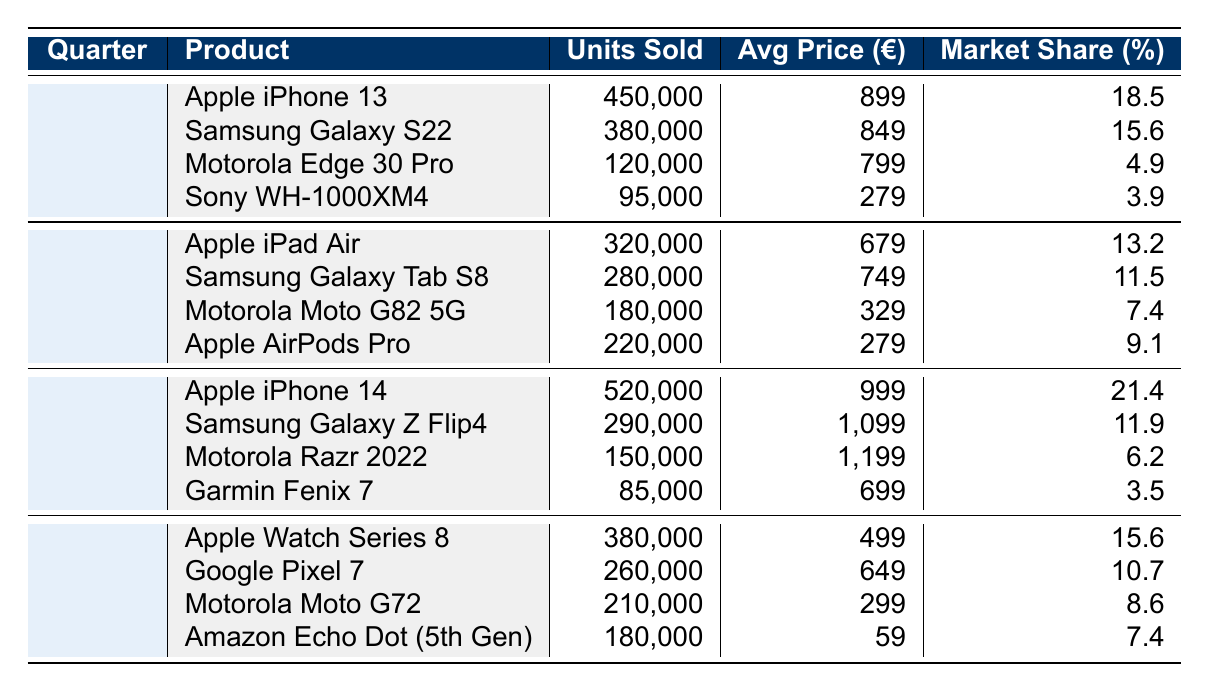What was the best-selling product in Q1 2022? In Q1 2022, the table shows that the Apple iPhone 13 sold 450,000 units, which is more than any other product listed for that quarter.
Answer: Apple iPhone 13 What was the average price of Motorola products sold in Q2 2022? In Q2 2022, the Motorola Moto G82 5G sold for 329€ and there were no other Motorola products listed for that quarter. Therefore, the average price is the same as the price of this one product: 329€.
Answer: 329€ Did the Samsung Galaxy S22 have a higher market share than the Motorola Edge 30 Pro in Q1 2022? The Samsung Galaxy S22 has a market share of 15.6% while the Motorola Edge 30 Pro has a market share of 4.9%. Since 15.6% is greater than 4.9%, the Samsung Galaxy S22 had a higher market share.
Answer: Yes How many total units were sold for Motorola products across all quarters in 2022? The total units sold for Motorola products are: 120,000 (Q1) + 180,000 (Q2) + 150,000 (Q3) + 210,000 (Q4) = 660,000 units.
Answer: 660,000 Which quarter had the highest total sales and what was the amount? By adding units sold in each quarter, we find: Q1 (450,000 + 380,000 + 120,000 + 95,000 = 1,045,000), Q2 (320,000 + 280,000 + 180,000 + 220,000 = 1,000,000), Q3 (520,000 + 290,000 + 150,000 + 85,000 = 1,045,000), and Q4 (380,000 + 260,000 + 210,000 + 180,000 = 1,030,000). Q1 and Q3 tie for the highest with 1,045,000 units.
Answer: Q1 and Q3, 1,045,000 What is the market share of the best-selling product in Q3 2022? The best-selling product in Q3 2022 was the Apple iPhone 14 with a market share of 21.4%.
Answer: 21.4% 